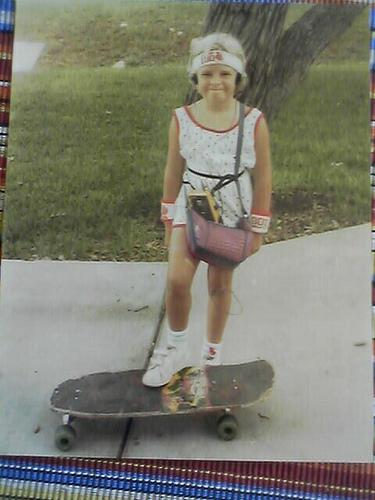How many boys are there?
Quick response, please. 0. Is this a vintage picture?
Write a very short answer. Yes. What is her foot resting on?
Give a very brief answer. Skateboard. Is her hair in a ponytail?
Keep it brief. No. What is being worn on her wrists?
Concise answer only. Wristbands. 